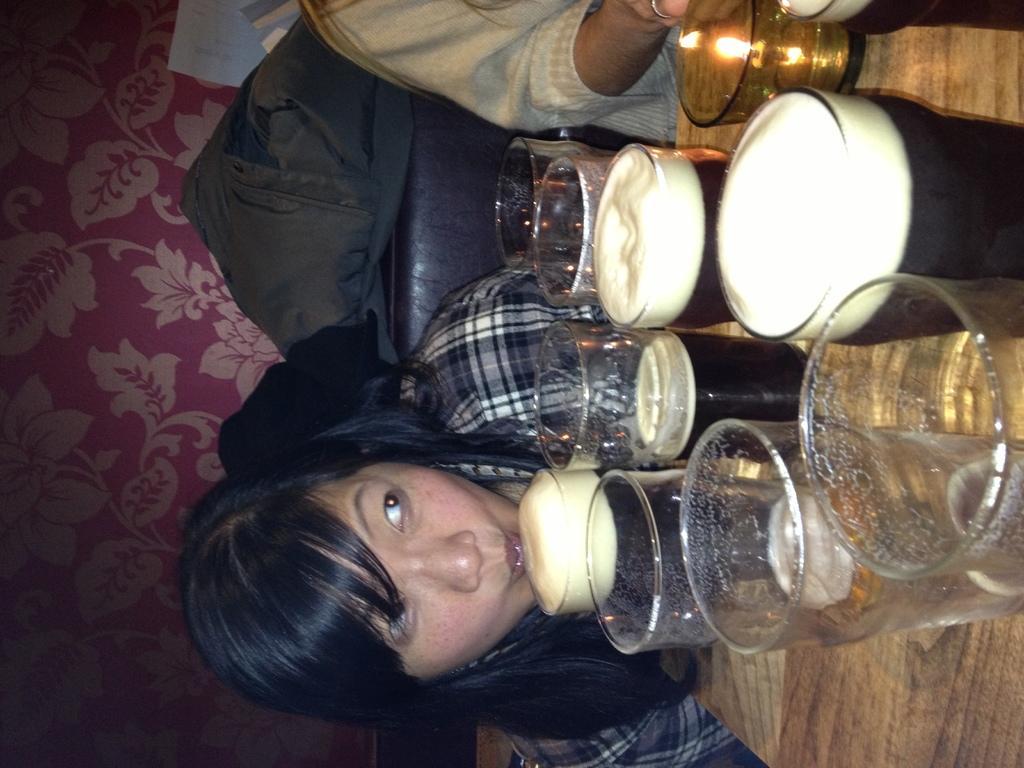How would you summarize this image in a sentence or two? In this picture I can see the brown color surface on which there are glasses and I see liquid in few glasses and I can see a glass in which there is light. In the background I can see a woman and another person and I see the designs on the left side of this picture. 